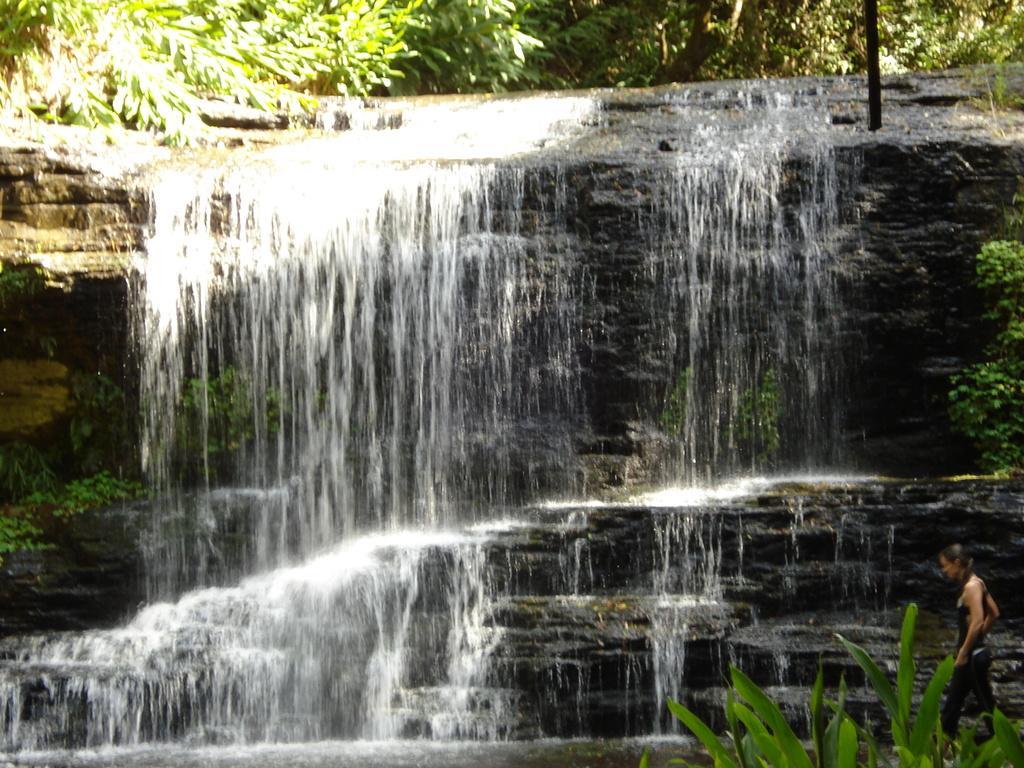Can you describe this image briefly? This picture is clicked outside the city. On the right there is a person standing on the ground and we can see the plants. In the center we can see the waterfall and the rocks, trees, plants and a pole. 